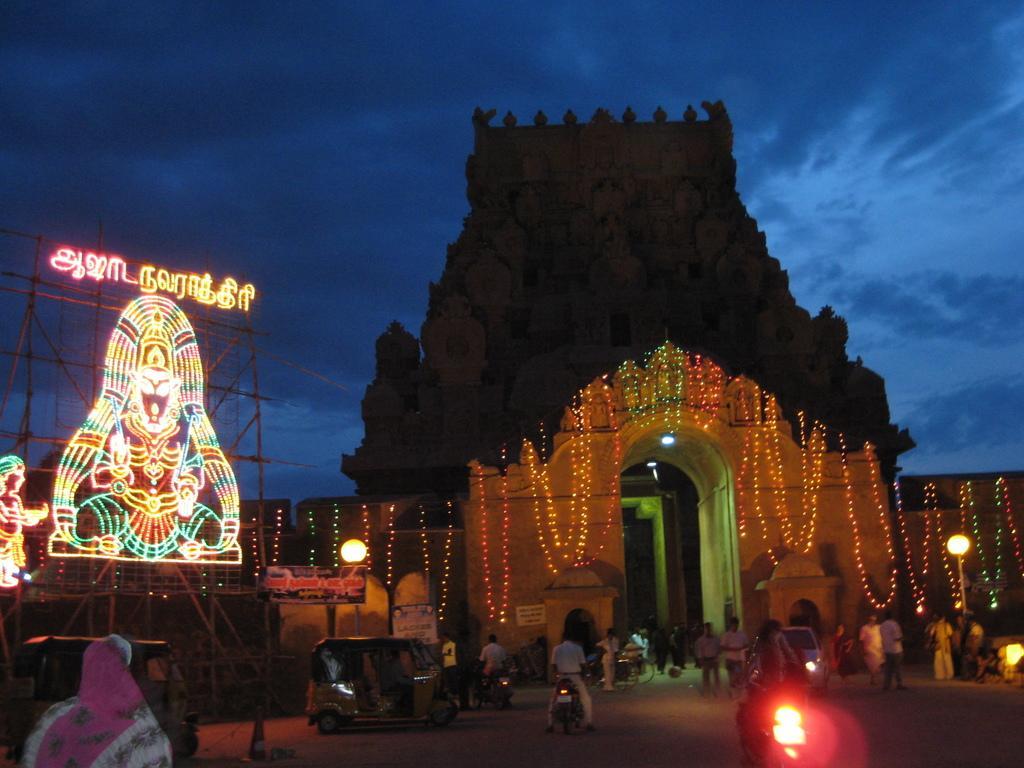Can you describe this image briefly? In the picture we can see a night view of a temple which is decorated with a light and we can also see some people walking in the temple and some are riding the bikes on the path and besides, we can see an auto rickshaw, and lights and we can see a sky which is blue in color. 